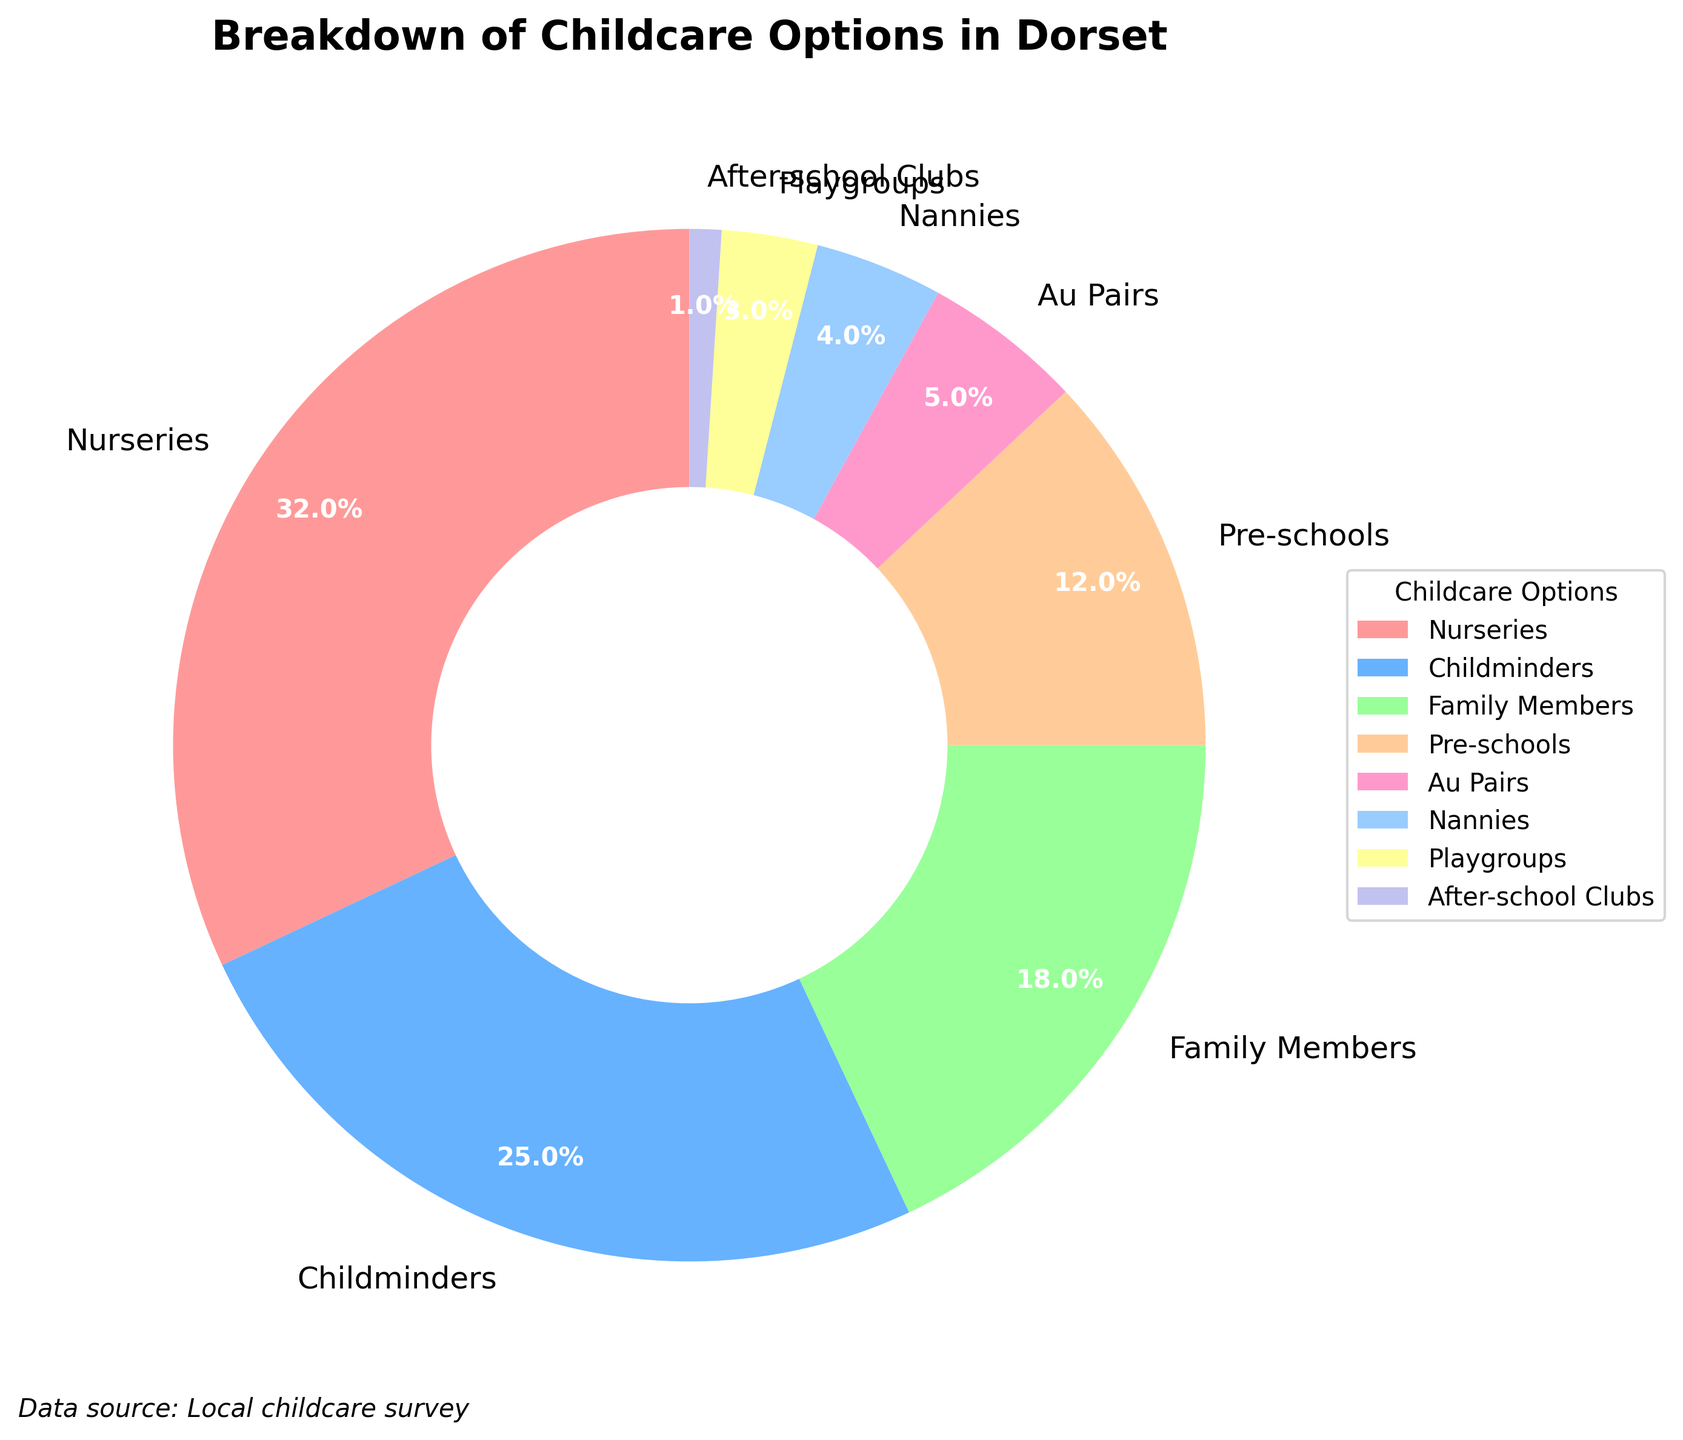What's the most common childcare option in Dorset? We can look at the pie chart to see which childcare option takes up the largest segment. Based on the data, nurseries make up 32% of the childcare options, which is the largest percentage.
Answer: Nurseries Which childcare options make up more than 20% of the chart? By inspecting the pie chart, we can identify the segments that are larger than one-fifth (20%). Nurseries make up 32% and childminders make up 25%.
Answer: Nurseries and Childminders What's the combined percentage of family members, pre-schools, and au pairs? To find the combined percentage, we add the percentages for family members (18%), pre-schools (12%), and au pairs (5%). The total is 18 + 12 + 5 = 35%.
Answer: 35% Which childcare option is the least common in Dorset? The smallest segment in the pie chart corresponds to after-school clubs, which make up 1% of the childcare options.
Answer: After-school Clubs How much more popular are nurseries compared to nannies? Nurseries have a percentage of 32% while nannies have 4%. The difference is 32 - 4 = 28%.
Answer: 28% What is the percentage difference between childminders and pre-schools? Childminders make up 25%, and pre-schools make up 12%. The difference is 25 - 12 = 13%.
Answer: 13% Which two options combined make up approximately half of the childcare options in Dorset? By adding the percentages, we see that nurseries (32%) and childminders (25%) combined make 32 + 25 = 57%, which is close to half (50%) of the total childcare options.
Answer: Nurseries and Childminders What is the second least common childcare option? After checking the pie chart, the second smallest segment is for playgroups, which make up 3% of the childcare options.
Answer: Playgroups Is the percentage of childcare provided by family members greater than those provided by au pairs and nannies combined? Family members provide 18%, and au pairs and nannies combined provide 5 + 4 = 9%. Since 18% is greater than 9%, family members provide more childcare.
Answer: Yes What is the average percentage for childcare provided by pre-schools, au pairs, and after-school clubs? Adding the percentages of pre-schools (12%), au pairs (5%), and after-school clubs (1%) gives us a total of 12 + 5 + 1 = 18%. The average is 18 / 3 = 6%.
Answer: 6% 